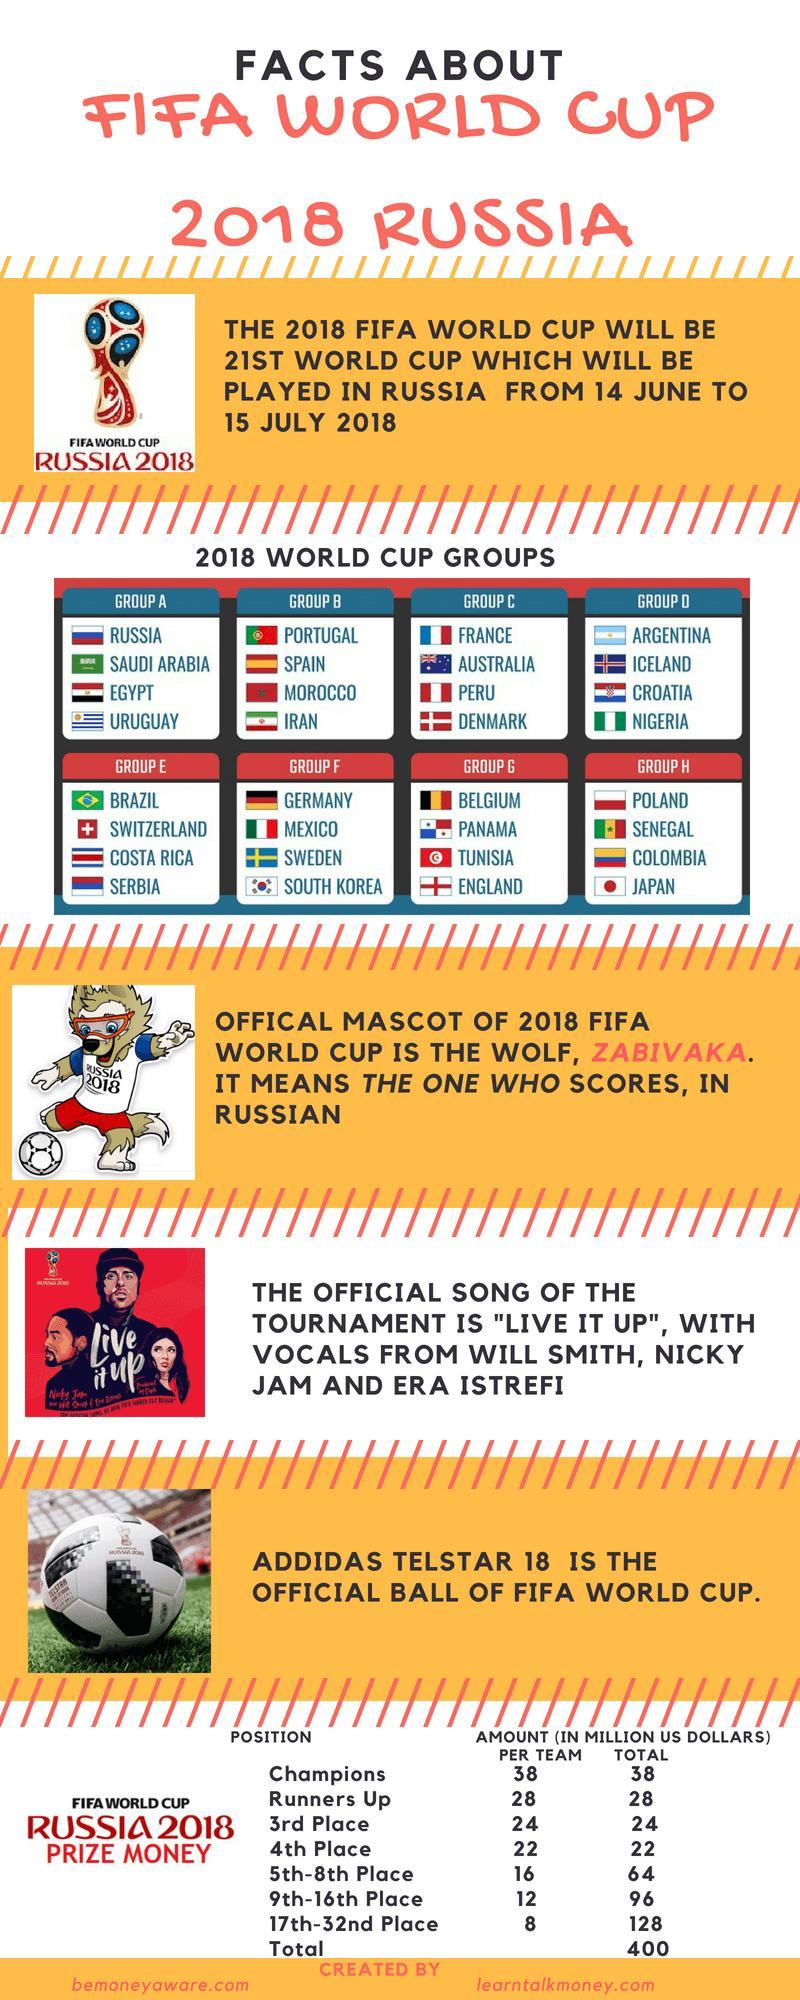how many teams were participated in FIFA world cup 2018?
Answer the question with a short phrase. 32 how much is the total prize money given to top three winning teams in million dollars? 90 How many teams are the 32 teams divided into? 8 How much less money will the first runner-up team receive than the champions in million dollars? 10 how much is the total prize money given to 10th place team in million dollars? 12 how much is the total prize money given to 20th place team in million dollars? 8 how much is the total prize money given to 7th place team in million dollars? 16 